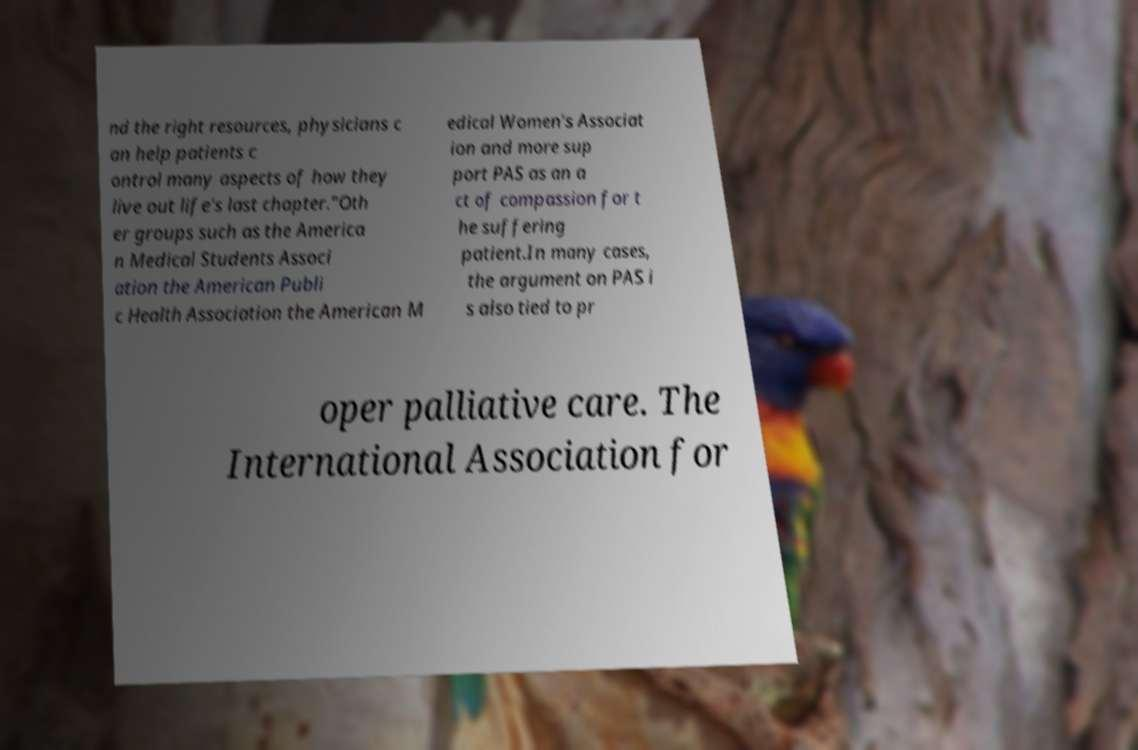For documentation purposes, I need the text within this image transcribed. Could you provide that? nd the right resources, physicians c an help patients c ontrol many aspects of how they live out life's last chapter."Oth er groups such as the America n Medical Students Associ ation the American Publi c Health Association the American M edical Women's Associat ion and more sup port PAS as an a ct of compassion for t he suffering patient.In many cases, the argument on PAS i s also tied to pr oper palliative care. The International Association for 